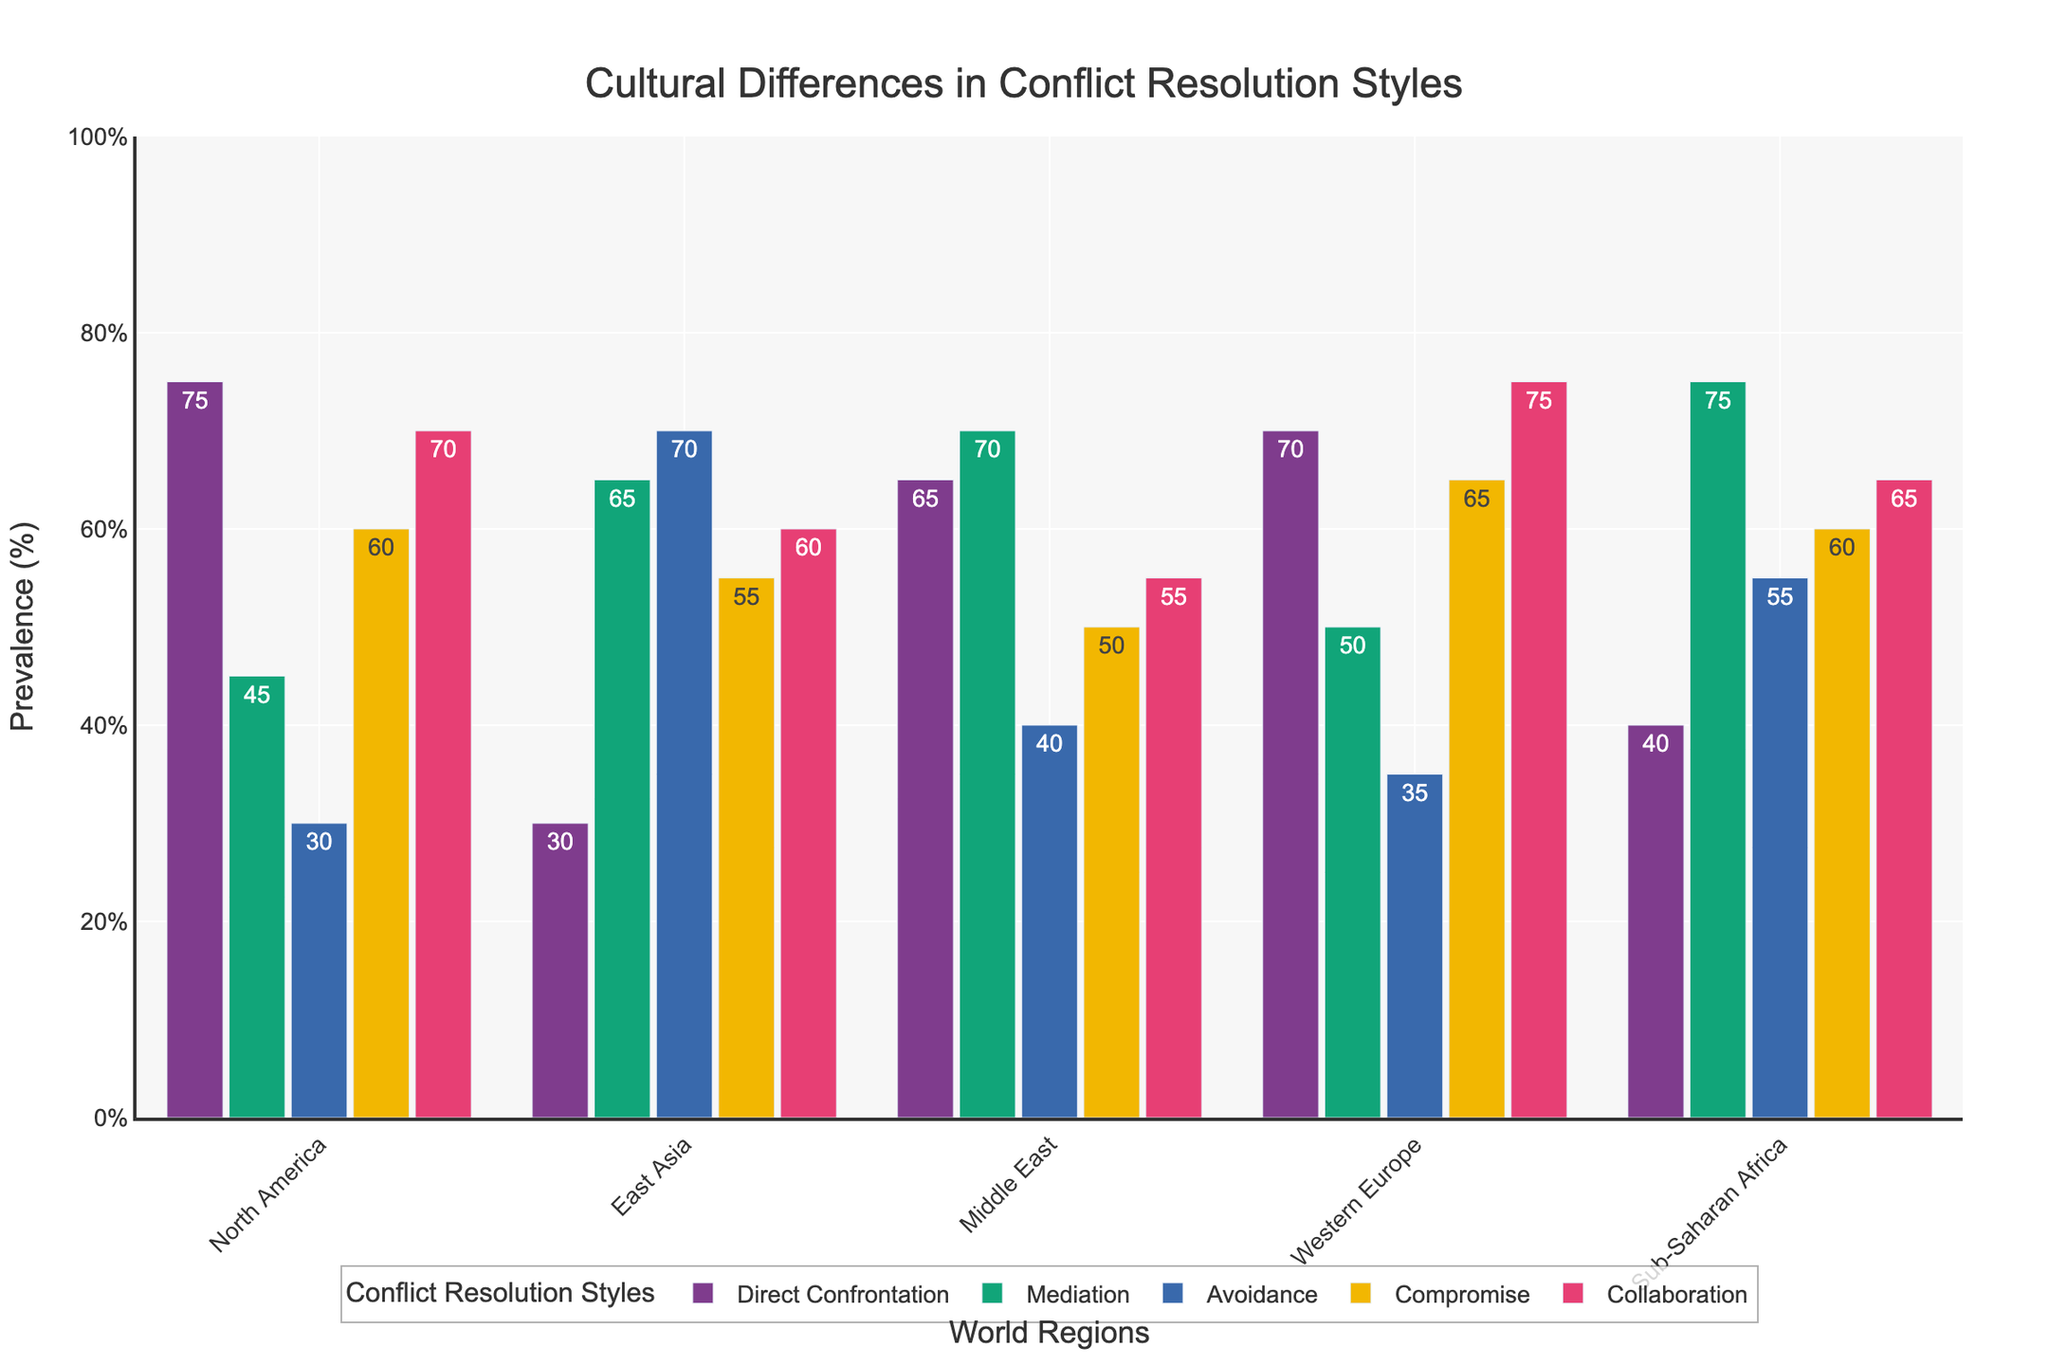Which region shows the highest prevalence of Direct Confrontation? The bar representing Direct Confrontation for North America is the tallest among all regions.
Answer: North America Which conflict resolution style is least prevalent in East Asia? The bar corresponding to Direct Confrontation is the shortest among all the styles in East Asia.
Answer: Direct Confrontation How do the prevalence rates of Mediation in the Middle East and Sub-Saharan Africa compare? The heights of the bars show that Mediation is at 70% in the Middle East and 75% in Sub-Saharan Africa, with Sub-Saharan Africa being higher.
Answer: Sub-Saharan Africa Which region has the most uniform distribution across all conflict resolution styles? Western Europe has bars that are relatively close in height for all conflict resolution styles, indicating a more uniform distribution.
Answer: Western Europe What is the difference in the prevalence of Avoidance between East Asia and North America? The bar for Avoidance in East Asia is at 70%, while in North America it is at 30%. The difference is 70% - 30% = 40%.
Answer: 40% If we sum the prevalence of Compromise and Collaboration in North America, what is the result? The bar for Compromise in North America is at 60%, and for Collaboration it is at 70%. Summing them gives 60% + 70% = 130%.
Answer: 130% Which region has the lowest prevalence of Collaboration? The shortest bar for Collaboration is in the Middle East, which is at 55%.
Answer: Middle East Compare the visual height of the bars for Compromise in North America and Western Europe. Which one is taller? By observing the heights, the bar for Compromise is taller in Western Europe (65%) compared to North America (60%).
Answer: Western Europe What is the average prevalence of Mediation and Compromise in Sub-Saharan Africa? Mediation is at 75% and Compromise at 60%, so the average would be (75% + 60%) / 2 = 67.5%.
Answer: 67.5% Which region has the highest combined prevalence of Direct Confrontation and Collaboration? For each region, summing Direct Confrontation and Collaboration: North America: 75% + 70% = 145%, East Asia: 30% + 60% = 90%, Middle East: 65% + 55% = 120%, Western Europe: 70% + 75% = 145%, Sub-Saharan Africa: 40% + 65% = 105%. North America and Western Europe are tied at 145%.
Answer: North America and Western Europe 